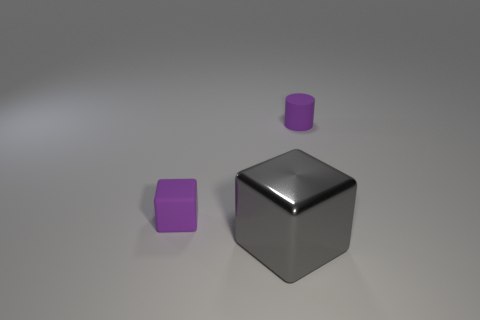Add 3 gray rubber objects. How many objects exist? 6 Subtract all gray cubes. How many cubes are left? 1 Subtract 1 cylinders. How many cylinders are left? 0 Subtract all blue cylinders. Subtract all yellow spheres. How many cylinders are left? 1 Subtract all gray cubes. Subtract all purple cylinders. How many objects are left? 1 Add 1 big gray cubes. How many big gray cubes are left? 2 Add 3 tiny purple matte objects. How many tiny purple matte objects exist? 5 Subtract 0 purple balls. How many objects are left? 3 Subtract all blocks. How many objects are left? 1 